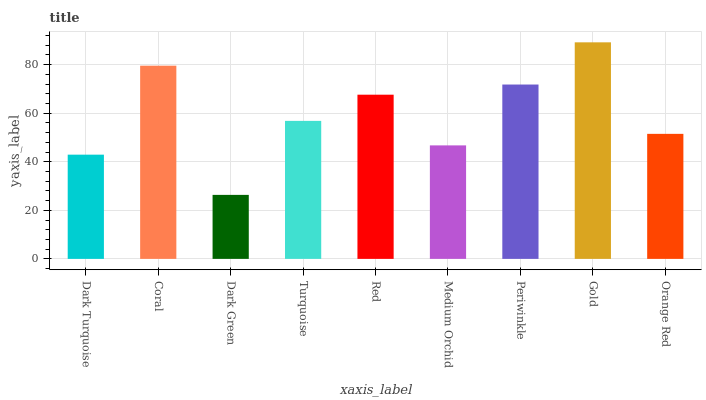Is Dark Green the minimum?
Answer yes or no. Yes. Is Gold the maximum?
Answer yes or no. Yes. Is Coral the minimum?
Answer yes or no. No. Is Coral the maximum?
Answer yes or no. No. Is Coral greater than Dark Turquoise?
Answer yes or no. Yes. Is Dark Turquoise less than Coral?
Answer yes or no. Yes. Is Dark Turquoise greater than Coral?
Answer yes or no. No. Is Coral less than Dark Turquoise?
Answer yes or no. No. Is Turquoise the high median?
Answer yes or no. Yes. Is Turquoise the low median?
Answer yes or no. Yes. Is Coral the high median?
Answer yes or no. No. Is Medium Orchid the low median?
Answer yes or no. No. 